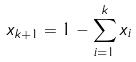<formula> <loc_0><loc_0><loc_500><loc_500>x _ { k + 1 } = 1 - \sum _ { i = 1 } ^ { k } x _ { i }</formula> 